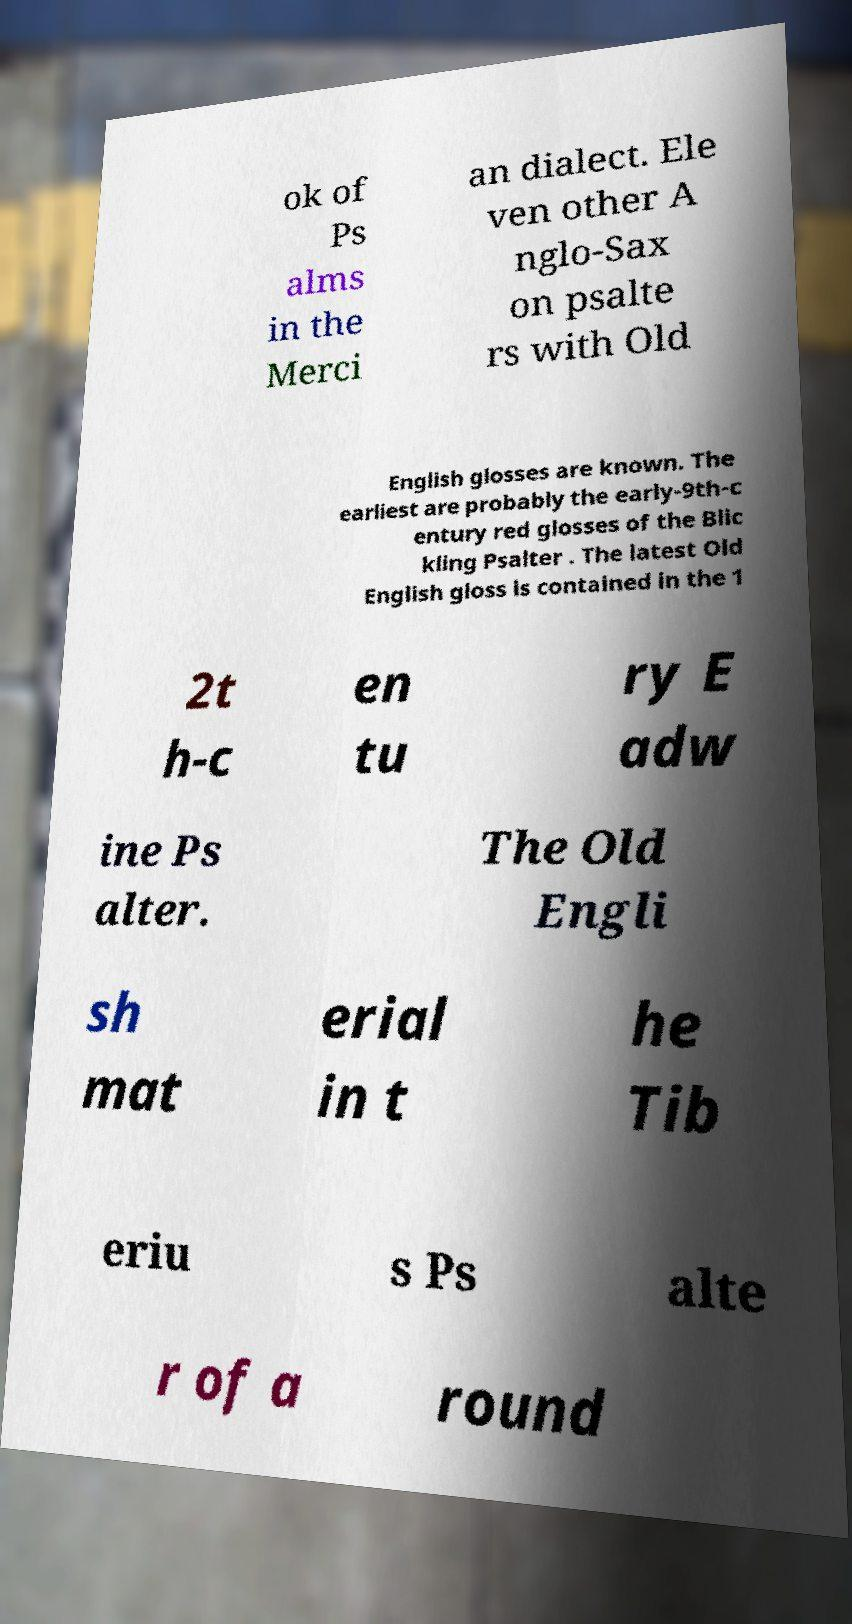I need the written content from this picture converted into text. Can you do that? ok of Ps alms in the Merci an dialect. Ele ven other A nglo-Sax on psalte rs with Old English glosses are known. The earliest are probably the early-9th-c entury red glosses of the Blic kling Psalter . The latest Old English gloss is contained in the 1 2t h-c en tu ry E adw ine Ps alter. The Old Engli sh mat erial in t he Tib eriu s Ps alte r of a round 